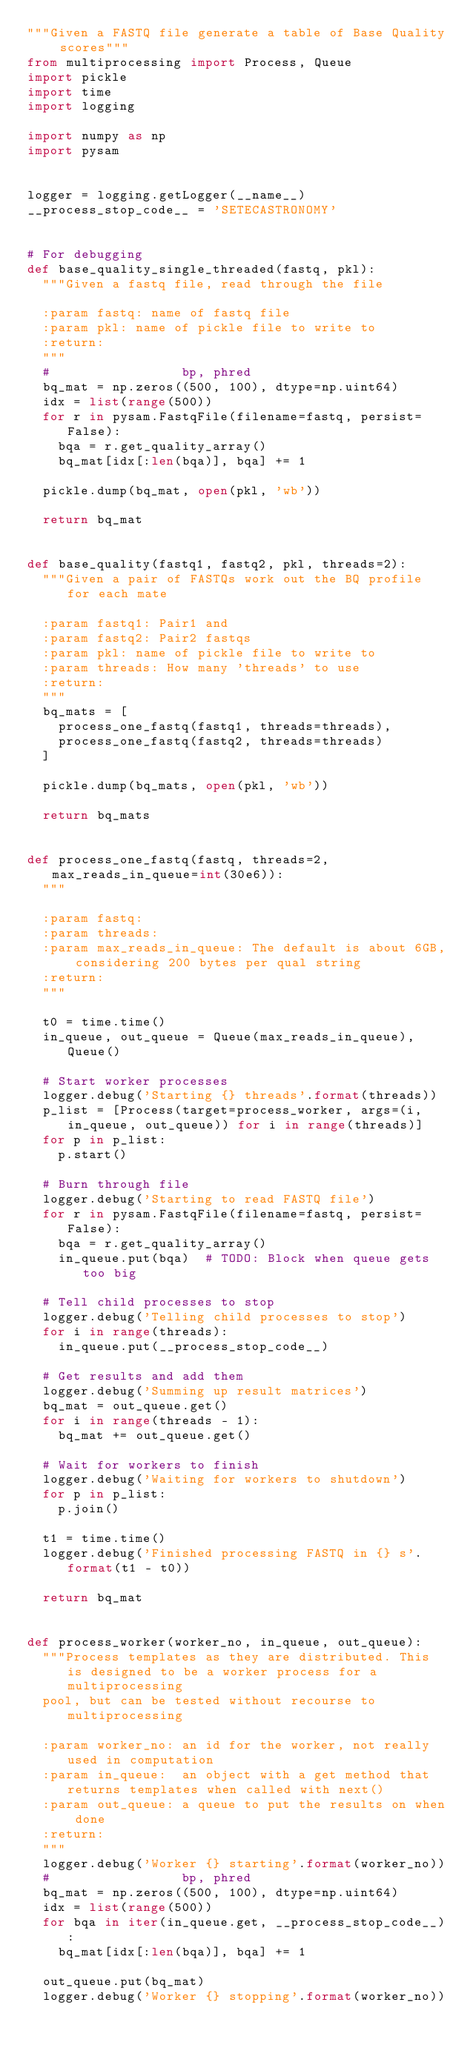Convert code to text. <code><loc_0><loc_0><loc_500><loc_500><_Python_>"""Given a FASTQ file generate a table of Base Quality scores"""
from multiprocessing import Process, Queue
import pickle
import time
import logging

import numpy as np
import pysam


logger = logging.getLogger(__name__)
__process_stop_code__ = 'SETECASTRONOMY'


# For debugging
def base_quality_single_threaded(fastq, pkl):
  """Given a fastq file, read through the file

  :param fastq: name of fastq file
  :param pkl: name of pickle file to write to
  :return:
  """
  #                 bp, phred
  bq_mat = np.zeros((500, 100), dtype=np.uint64)
  idx = list(range(500))
  for r in pysam.FastqFile(filename=fastq, persist=False):
    bqa = r.get_quality_array()
    bq_mat[idx[:len(bqa)], bqa] += 1

  pickle.dump(bq_mat, open(pkl, 'wb'))

  return bq_mat


def base_quality(fastq1, fastq2, pkl, threads=2):
  """Given a pair of FASTQs work out the BQ profile for each mate

  :param fastq1: Pair1 and
  :param fastq2: Pair2 fastqs
  :param pkl: name of pickle file to write to
  :param threads: How many 'threads' to use
  :return:
  """
  bq_mats = [
    process_one_fastq(fastq1, threads=threads),
    process_one_fastq(fastq2, threads=threads)
  ]

  pickle.dump(bq_mats, open(pkl, 'wb'))

  return bq_mats


def process_one_fastq(fastq, threads=2, max_reads_in_queue=int(30e6)):
  """

  :param fastq:
  :param threads:
  :param max_reads_in_queue: The default is about 6GB, considering 200 bytes per qual string
  :return:
  """

  t0 = time.time()
  in_queue, out_queue = Queue(max_reads_in_queue), Queue()

  # Start worker processes
  logger.debug('Starting {} threads'.format(threads))
  p_list = [Process(target=process_worker, args=(i, in_queue, out_queue)) for i in range(threads)]
  for p in p_list:
    p.start()

  # Burn through file
  logger.debug('Starting to read FASTQ file')
  for r in pysam.FastqFile(filename=fastq, persist=False):
    bqa = r.get_quality_array()
    in_queue.put(bqa)  # TODO: Block when queue gets too big

  # Tell child processes to stop
  logger.debug('Telling child processes to stop')
  for i in range(threads):
    in_queue.put(__process_stop_code__)

  # Get results and add them
  logger.debug('Summing up result matrices')
  bq_mat = out_queue.get()
  for i in range(threads - 1):
    bq_mat += out_queue.get()

  # Wait for workers to finish
  logger.debug('Waiting for workers to shutdown')
  for p in p_list:
    p.join()

  t1 = time.time()
  logger.debug('Finished processing FASTQ in {} s'.format(t1 - t0))

  return bq_mat


def process_worker(worker_no, in_queue, out_queue):
  """Process templates as they are distributed. This is designed to be a worker process for a multiprocessing
  pool, but can be tested without recourse to multiprocessing

  :param worker_no: an id for the worker, not really used in computation
  :param in_queue:  an object with a get method that returns templates when called with next()
  :param out_queue: a queue to put the results on when done
  :return:
  """
  logger.debug('Worker {} starting'.format(worker_no))
  #                 bp, phred
  bq_mat = np.zeros((500, 100), dtype=np.uint64)
  idx = list(range(500))
  for bqa in iter(in_queue.get, __process_stop_code__):
    bq_mat[idx[:len(bqa)], bqa] += 1

  out_queue.put(bq_mat)
  logger.debug('Worker {} stopping'.format(worker_no))</code> 